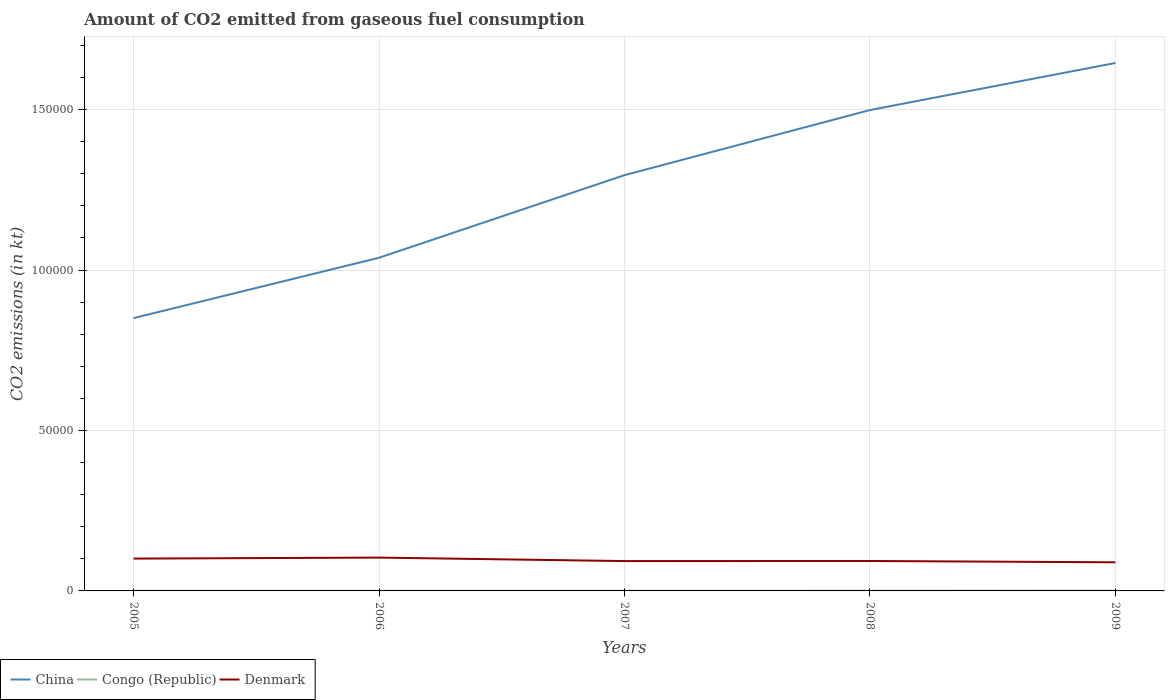Does the line corresponding to Congo (Republic) intersect with the line corresponding to Denmark?
Offer a very short reply. No. Is the number of lines equal to the number of legend labels?
Give a very brief answer. Yes. Across all years, what is the maximum amount of CO2 emitted in Denmark?
Make the answer very short. 8921.81. In which year was the amount of CO2 emitted in China maximum?
Give a very brief answer. 2005. What is the total amount of CO2 emitted in China in the graph?
Give a very brief answer. -6.07e+04. What is the difference between the highest and the second highest amount of CO2 emitted in Denmark?
Your response must be concise. 1466.8. How many years are there in the graph?
Offer a very short reply. 5. Are the values on the major ticks of Y-axis written in scientific E-notation?
Offer a very short reply. No. How many legend labels are there?
Ensure brevity in your answer.  3. What is the title of the graph?
Ensure brevity in your answer.  Amount of CO2 emitted from gaseous fuel consumption. What is the label or title of the X-axis?
Provide a succinct answer. Years. What is the label or title of the Y-axis?
Your answer should be very brief. CO2 emissions (in kt). What is the CO2 emissions (in kt) of China in 2005?
Make the answer very short. 8.50e+04. What is the CO2 emissions (in kt) in Congo (Republic) in 2005?
Your answer should be very brief. 44. What is the CO2 emissions (in kt) of Denmark in 2005?
Your answer should be compact. 1.01e+04. What is the CO2 emissions (in kt) of China in 2006?
Your answer should be very brief. 1.04e+05. What is the CO2 emissions (in kt) in Congo (Republic) in 2006?
Your response must be concise. 44. What is the CO2 emissions (in kt) of Denmark in 2006?
Offer a very short reply. 1.04e+04. What is the CO2 emissions (in kt) of China in 2007?
Provide a succinct answer. 1.30e+05. What is the CO2 emissions (in kt) in Congo (Republic) in 2007?
Your answer should be compact. 40.34. What is the CO2 emissions (in kt) of Denmark in 2007?
Make the answer very short. 9303.18. What is the CO2 emissions (in kt) in China in 2008?
Make the answer very short. 1.50e+05. What is the CO2 emissions (in kt) of Congo (Republic) in 2008?
Your response must be concise. 47.67. What is the CO2 emissions (in kt) of Denmark in 2008?
Your answer should be very brief. 9328.85. What is the CO2 emissions (in kt) of China in 2009?
Offer a very short reply. 1.65e+05. What is the CO2 emissions (in kt) in Congo (Republic) in 2009?
Provide a short and direct response. 106.34. What is the CO2 emissions (in kt) in Denmark in 2009?
Provide a short and direct response. 8921.81. Across all years, what is the maximum CO2 emissions (in kt) in China?
Provide a short and direct response. 1.65e+05. Across all years, what is the maximum CO2 emissions (in kt) of Congo (Republic)?
Offer a very short reply. 106.34. Across all years, what is the maximum CO2 emissions (in kt) of Denmark?
Provide a succinct answer. 1.04e+04. Across all years, what is the minimum CO2 emissions (in kt) in China?
Provide a succinct answer. 8.50e+04. Across all years, what is the minimum CO2 emissions (in kt) of Congo (Republic)?
Offer a terse response. 40.34. Across all years, what is the minimum CO2 emissions (in kt) in Denmark?
Give a very brief answer. 8921.81. What is the total CO2 emissions (in kt) in China in the graph?
Offer a very short reply. 6.33e+05. What is the total CO2 emissions (in kt) in Congo (Republic) in the graph?
Your answer should be very brief. 282.36. What is the total CO2 emissions (in kt) in Denmark in the graph?
Your answer should be very brief. 4.80e+04. What is the difference between the CO2 emissions (in kt) of China in 2005 and that in 2006?
Ensure brevity in your answer.  -1.88e+04. What is the difference between the CO2 emissions (in kt) in Denmark in 2005 and that in 2006?
Provide a succinct answer. -311.69. What is the difference between the CO2 emissions (in kt) in China in 2005 and that in 2007?
Give a very brief answer. -4.46e+04. What is the difference between the CO2 emissions (in kt) in Congo (Republic) in 2005 and that in 2007?
Make the answer very short. 3.67. What is the difference between the CO2 emissions (in kt) in Denmark in 2005 and that in 2007?
Your answer should be compact. 773.74. What is the difference between the CO2 emissions (in kt) of China in 2005 and that in 2008?
Provide a short and direct response. -6.48e+04. What is the difference between the CO2 emissions (in kt) in Congo (Republic) in 2005 and that in 2008?
Ensure brevity in your answer.  -3.67. What is the difference between the CO2 emissions (in kt) in Denmark in 2005 and that in 2008?
Provide a short and direct response. 748.07. What is the difference between the CO2 emissions (in kt) in China in 2005 and that in 2009?
Ensure brevity in your answer.  -7.95e+04. What is the difference between the CO2 emissions (in kt) in Congo (Republic) in 2005 and that in 2009?
Your answer should be compact. -62.34. What is the difference between the CO2 emissions (in kt) of Denmark in 2005 and that in 2009?
Your answer should be compact. 1155.11. What is the difference between the CO2 emissions (in kt) in China in 2006 and that in 2007?
Ensure brevity in your answer.  -2.57e+04. What is the difference between the CO2 emissions (in kt) of Congo (Republic) in 2006 and that in 2007?
Your answer should be very brief. 3.67. What is the difference between the CO2 emissions (in kt) in Denmark in 2006 and that in 2007?
Your response must be concise. 1085.43. What is the difference between the CO2 emissions (in kt) of China in 2006 and that in 2008?
Provide a short and direct response. -4.60e+04. What is the difference between the CO2 emissions (in kt) of Congo (Republic) in 2006 and that in 2008?
Keep it short and to the point. -3.67. What is the difference between the CO2 emissions (in kt) of Denmark in 2006 and that in 2008?
Offer a very short reply. 1059.76. What is the difference between the CO2 emissions (in kt) of China in 2006 and that in 2009?
Make the answer very short. -6.07e+04. What is the difference between the CO2 emissions (in kt) in Congo (Republic) in 2006 and that in 2009?
Make the answer very short. -62.34. What is the difference between the CO2 emissions (in kt) in Denmark in 2006 and that in 2009?
Offer a terse response. 1466.8. What is the difference between the CO2 emissions (in kt) in China in 2007 and that in 2008?
Provide a succinct answer. -2.03e+04. What is the difference between the CO2 emissions (in kt) of Congo (Republic) in 2007 and that in 2008?
Offer a terse response. -7.33. What is the difference between the CO2 emissions (in kt) in Denmark in 2007 and that in 2008?
Make the answer very short. -25.67. What is the difference between the CO2 emissions (in kt) of China in 2007 and that in 2009?
Make the answer very short. -3.50e+04. What is the difference between the CO2 emissions (in kt) in Congo (Republic) in 2007 and that in 2009?
Your response must be concise. -66.01. What is the difference between the CO2 emissions (in kt) of Denmark in 2007 and that in 2009?
Keep it short and to the point. 381.37. What is the difference between the CO2 emissions (in kt) of China in 2008 and that in 2009?
Keep it short and to the point. -1.47e+04. What is the difference between the CO2 emissions (in kt) of Congo (Republic) in 2008 and that in 2009?
Provide a short and direct response. -58.67. What is the difference between the CO2 emissions (in kt) of Denmark in 2008 and that in 2009?
Your answer should be very brief. 407.04. What is the difference between the CO2 emissions (in kt) of China in 2005 and the CO2 emissions (in kt) of Congo (Republic) in 2006?
Keep it short and to the point. 8.50e+04. What is the difference between the CO2 emissions (in kt) in China in 2005 and the CO2 emissions (in kt) in Denmark in 2006?
Provide a short and direct response. 7.46e+04. What is the difference between the CO2 emissions (in kt) of Congo (Republic) in 2005 and the CO2 emissions (in kt) of Denmark in 2006?
Give a very brief answer. -1.03e+04. What is the difference between the CO2 emissions (in kt) of China in 2005 and the CO2 emissions (in kt) of Congo (Republic) in 2007?
Provide a succinct answer. 8.50e+04. What is the difference between the CO2 emissions (in kt) in China in 2005 and the CO2 emissions (in kt) in Denmark in 2007?
Offer a very short reply. 7.57e+04. What is the difference between the CO2 emissions (in kt) of Congo (Republic) in 2005 and the CO2 emissions (in kt) of Denmark in 2007?
Offer a terse response. -9259.17. What is the difference between the CO2 emissions (in kt) in China in 2005 and the CO2 emissions (in kt) in Congo (Republic) in 2008?
Your response must be concise. 8.50e+04. What is the difference between the CO2 emissions (in kt) of China in 2005 and the CO2 emissions (in kt) of Denmark in 2008?
Your answer should be compact. 7.57e+04. What is the difference between the CO2 emissions (in kt) in Congo (Republic) in 2005 and the CO2 emissions (in kt) in Denmark in 2008?
Provide a short and direct response. -9284.84. What is the difference between the CO2 emissions (in kt) in China in 2005 and the CO2 emissions (in kt) in Congo (Republic) in 2009?
Your answer should be compact. 8.49e+04. What is the difference between the CO2 emissions (in kt) in China in 2005 and the CO2 emissions (in kt) in Denmark in 2009?
Your response must be concise. 7.61e+04. What is the difference between the CO2 emissions (in kt) of Congo (Republic) in 2005 and the CO2 emissions (in kt) of Denmark in 2009?
Provide a succinct answer. -8877.81. What is the difference between the CO2 emissions (in kt) in China in 2006 and the CO2 emissions (in kt) in Congo (Republic) in 2007?
Offer a very short reply. 1.04e+05. What is the difference between the CO2 emissions (in kt) in China in 2006 and the CO2 emissions (in kt) in Denmark in 2007?
Your answer should be very brief. 9.45e+04. What is the difference between the CO2 emissions (in kt) in Congo (Republic) in 2006 and the CO2 emissions (in kt) in Denmark in 2007?
Provide a succinct answer. -9259.17. What is the difference between the CO2 emissions (in kt) of China in 2006 and the CO2 emissions (in kt) of Congo (Republic) in 2008?
Offer a very short reply. 1.04e+05. What is the difference between the CO2 emissions (in kt) in China in 2006 and the CO2 emissions (in kt) in Denmark in 2008?
Offer a terse response. 9.45e+04. What is the difference between the CO2 emissions (in kt) in Congo (Republic) in 2006 and the CO2 emissions (in kt) in Denmark in 2008?
Make the answer very short. -9284.84. What is the difference between the CO2 emissions (in kt) in China in 2006 and the CO2 emissions (in kt) in Congo (Republic) in 2009?
Offer a very short reply. 1.04e+05. What is the difference between the CO2 emissions (in kt) of China in 2006 and the CO2 emissions (in kt) of Denmark in 2009?
Offer a terse response. 9.49e+04. What is the difference between the CO2 emissions (in kt) of Congo (Republic) in 2006 and the CO2 emissions (in kt) of Denmark in 2009?
Provide a short and direct response. -8877.81. What is the difference between the CO2 emissions (in kt) of China in 2007 and the CO2 emissions (in kt) of Congo (Republic) in 2008?
Provide a short and direct response. 1.30e+05. What is the difference between the CO2 emissions (in kt) in China in 2007 and the CO2 emissions (in kt) in Denmark in 2008?
Your answer should be very brief. 1.20e+05. What is the difference between the CO2 emissions (in kt) of Congo (Republic) in 2007 and the CO2 emissions (in kt) of Denmark in 2008?
Your answer should be compact. -9288.51. What is the difference between the CO2 emissions (in kt) of China in 2007 and the CO2 emissions (in kt) of Congo (Republic) in 2009?
Provide a succinct answer. 1.29e+05. What is the difference between the CO2 emissions (in kt) in China in 2007 and the CO2 emissions (in kt) in Denmark in 2009?
Your answer should be very brief. 1.21e+05. What is the difference between the CO2 emissions (in kt) in Congo (Republic) in 2007 and the CO2 emissions (in kt) in Denmark in 2009?
Give a very brief answer. -8881.47. What is the difference between the CO2 emissions (in kt) in China in 2008 and the CO2 emissions (in kt) in Congo (Republic) in 2009?
Keep it short and to the point. 1.50e+05. What is the difference between the CO2 emissions (in kt) in China in 2008 and the CO2 emissions (in kt) in Denmark in 2009?
Offer a very short reply. 1.41e+05. What is the difference between the CO2 emissions (in kt) of Congo (Republic) in 2008 and the CO2 emissions (in kt) of Denmark in 2009?
Your answer should be very brief. -8874.14. What is the average CO2 emissions (in kt) of China per year?
Your answer should be compact. 1.27e+05. What is the average CO2 emissions (in kt) of Congo (Republic) per year?
Offer a very short reply. 56.47. What is the average CO2 emissions (in kt) in Denmark per year?
Ensure brevity in your answer.  9603.87. In the year 2005, what is the difference between the CO2 emissions (in kt) of China and CO2 emissions (in kt) of Congo (Republic)?
Provide a succinct answer. 8.50e+04. In the year 2005, what is the difference between the CO2 emissions (in kt) in China and CO2 emissions (in kt) in Denmark?
Keep it short and to the point. 7.49e+04. In the year 2005, what is the difference between the CO2 emissions (in kt) of Congo (Republic) and CO2 emissions (in kt) of Denmark?
Your response must be concise. -1.00e+04. In the year 2006, what is the difference between the CO2 emissions (in kt) of China and CO2 emissions (in kt) of Congo (Republic)?
Provide a succinct answer. 1.04e+05. In the year 2006, what is the difference between the CO2 emissions (in kt) of China and CO2 emissions (in kt) of Denmark?
Your response must be concise. 9.34e+04. In the year 2006, what is the difference between the CO2 emissions (in kt) of Congo (Republic) and CO2 emissions (in kt) of Denmark?
Make the answer very short. -1.03e+04. In the year 2007, what is the difference between the CO2 emissions (in kt) in China and CO2 emissions (in kt) in Congo (Republic)?
Your response must be concise. 1.30e+05. In the year 2007, what is the difference between the CO2 emissions (in kt) of China and CO2 emissions (in kt) of Denmark?
Make the answer very short. 1.20e+05. In the year 2007, what is the difference between the CO2 emissions (in kt) of Congo (Republic) and CO2 emissions (in kt) of Denmark?
Your answer should be very brief. -9262.84. In the year 2008, what is the difference between the CO2 emissions (in kt) in China and CO2 emissions (in kt) in Congo (Republic)?
Your answer should be very brief. 1.50e+05. In the year 2008, what is the difference between the CO2 emissions (in kt) in China and CO2 emissions (in kt) in Denmark?
Ensure brevity in your answer.  1.41e+05. In the year 2008, what is the difference between the CO2 emissions (in kt) of Congo (Republic) and CO2 emissions (in kt) of Denmark?
Provide a succinct answer. -9281.18. In the year 2009, what is the difference between the CO2 emissions (in kt) in China and CO2 emissions (in kt) in Congo (Republic)?
Your response must be concise. 1.64e+05. In the year 2009, what is the difference between the CO2 emissions (in kt) of China and CO2 emissions (in kt) of Denmark?
Provide a succinct answer. 1.56e+05. In the year 2009, what is the difference between the CO2 emissions (in kt) of Congo (Republic) and CO2 emissions (in kt) of Denmark?
Make the answer very short. -8815.47. What is the ratio of the CO2 emissions (in kt) of China in 2005 to that in 2006?
Your answer should be compact. 0.82. What is the ratio of the CO2 emissions (in kt) of Congo (Republic) in 2005 to that in 2006?
Provide a short and direct response. 1. What is the ratio of the CO2 emissions (in kt) of China in 2005 to that in 2007?
Offer a very short reply. 0.66. What is the ratio of the CO2 emissions (in kt) in Denmark in 2005 to that in 2007?
Your answer should be compact. 1.08. What is the ratio of the CO2 emissions (in kt) of China in 2005 to that in 2008?
Your answer should be very brief. 0.57. What is the ratio of the CO2 emissions (in kt) in Congo (Republic) in 2005 to that in 2008?
Offer a very short reply. 0.92. What is the ratio of the CO2 emissions (in kt) of Denmark in 2005 to that in 2008?
Your answer should be compact. 1.08. What is the ratio of the CO2 emissions (in kt) of China in 2005 to that in 2009?
Offer a terse response. 0.52. What is the ratio of the CO2 emissions (in kt) in Congo (Republic) in 2005 to that in 2009?
Provide a succinct answer. 0.41. What is the ratio of the CO2 emissions (in kt) in Denmark in 2005 to that in 2009?
Provide a succinct answer. 1.13. What is the ratio of the CO2 emissions (in kt) in China in 2006 to that in 2007?
Offer a very short reply. 0.8. What is the ratio of the CO2 emissions (in kt) of Congo (Republic) in 2006 to that in 2007?
Make the answer very short. 1.09. What is the ratio of the CO2 emissions (in kt) in Denmark in 2006 to that in 2007?
Provide a short and direct response. 1.12. What is the ratio of the CO2 emissions (in kt) of China in 2006 to that in 2008?
Your answer should be very brief. 0.69. What is the ratio of the CO2 emissions (in kt) of Denmark in 2006 to that in 2008?
Provide a short and direct response. 1.11. What is the ratio of the CO2 emissions (in kt) in China in 2006 to that in 2009?
Provide a short and direct response. 0.63. What is the ratio of the CO2 emissions (in kt) of Congo (Republic) in 2006 to that in 2009?
Your answer should be compact. 0.41. What is the ratio of the CO2 emissions (in kt) in Denmark in 2006 to that in 2009?
Provide a short and direct response. 1.16. What is the ratio of the CO2 emissions (in kt) of China in 2007 to that in 2008?
Your answer should be very brief. 0.86. What is the ratio of the CO2 emissions (in kt) in Congo (Republic) in 2007 to that in 2008?
Give a very brief answer. 0.85. What is the ratio of the CO2 emissions (in kt) in Denmark in 2007 to that in 2008?
Ensure brevity in your answer.  1. What is the ratio of the CO2 emissions (in kt) of China in 2007 to that in 2009?
Give a very brief answer. 0.79. What is the ratio of the CO2 emissions (in kt) of Congo (Republic) in 2007 to that in 2009?
Keep it short and to the point. 0.38. What is the ratio of the CO2 emissions (in kt) in Denmark in 2007 to that in 2009?
Keep it short and to the point. 1.04. What is the ratio of the CO2 emissions (in kt) of China in 2008 to that in 2009?
Provide a short and direct response. 0.91. What is the ratio of the CO2 emissions (in kt) of Congo (Republic) in 2008 to that in 2009?
Make the answer very short. 0.45. What is the ratio of the CO2 emissions (in kt) of Denmark in 2008 to that in 2009?
Your response must be concise. 1.05. What is the difference between the highest and the second highest CO2 emissions (in kt) in China?
Your response must be concise. 1.47e+04. What is the difference between the highest and the second highest CO2 emissions (in kt) of Congo (Republic)?
Your answer should be compact. 58.67. What is the difference between the highest and the second highest CO2 emissions (in kt) in Denmark?
Ensure brevity in your answer.  311.69. What is the difference between the highest and the lowest CO2 emissions (in kt) of China?
Ensure brevity in your answer.  7.95e+04. What is the difference between the highest and the lowest CO2 emissions (in kt) in Congo (Republic)?
Your answer should be compact. 66.01. What is the difference between the highest and the lowest CO2 emissions (in kt) of Denmark?
Your answer should be compact. 1466.8. 